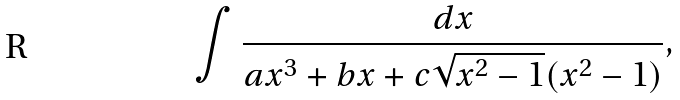Convert formula to latex. <formula><loc_0><loc_0><loc_500><loc_500>\int \frac { d x } { a x ^ { 3 } + b x + c \sqrt { x ^ { 2 } - 1 } ( x ^ { 2 } - 1 ) } ,</formula> 